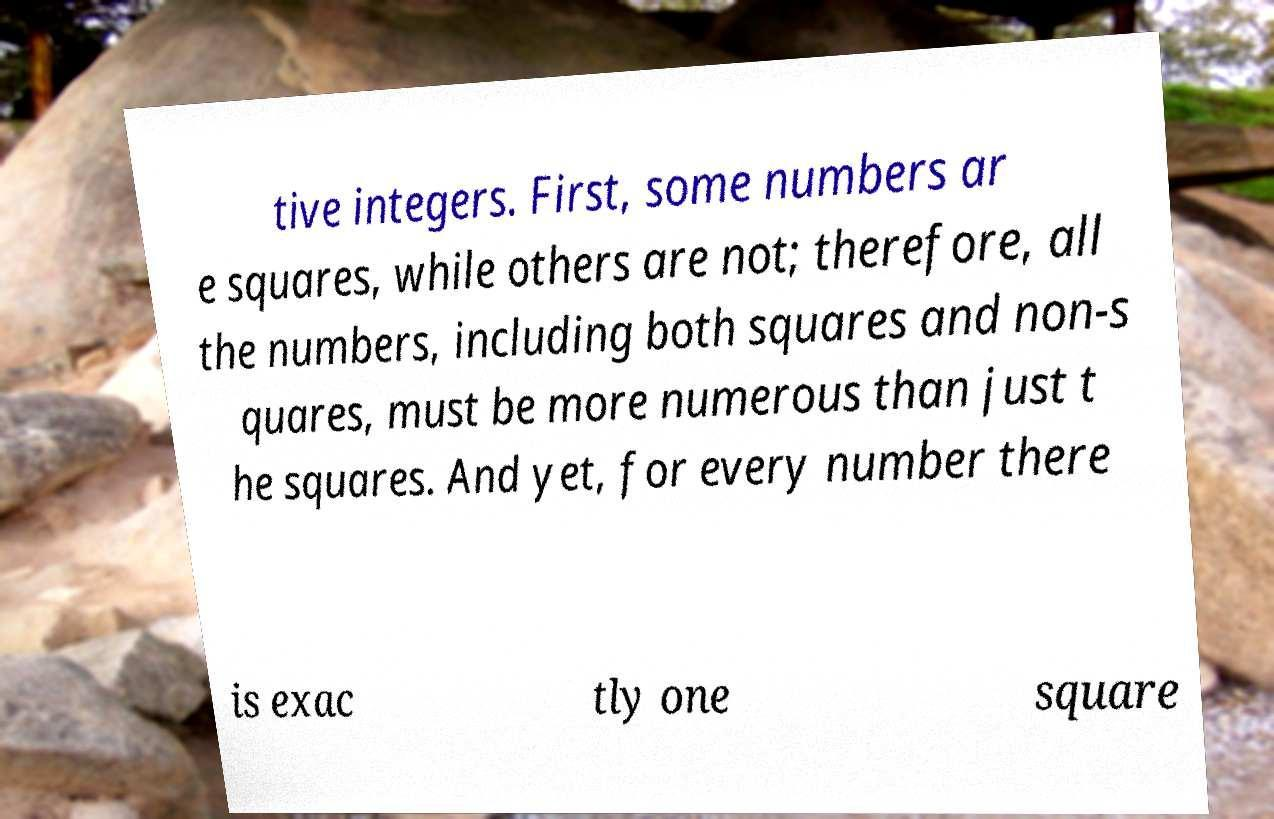Please read and relay the text visible in this image. What does it say? tive integers. First, some numbers ar e squares, while others are not; therefore, all the numbers, including both squares and non-s quares, must be more numerous than just t he squares. And yet, for every number there is exac tly one square 